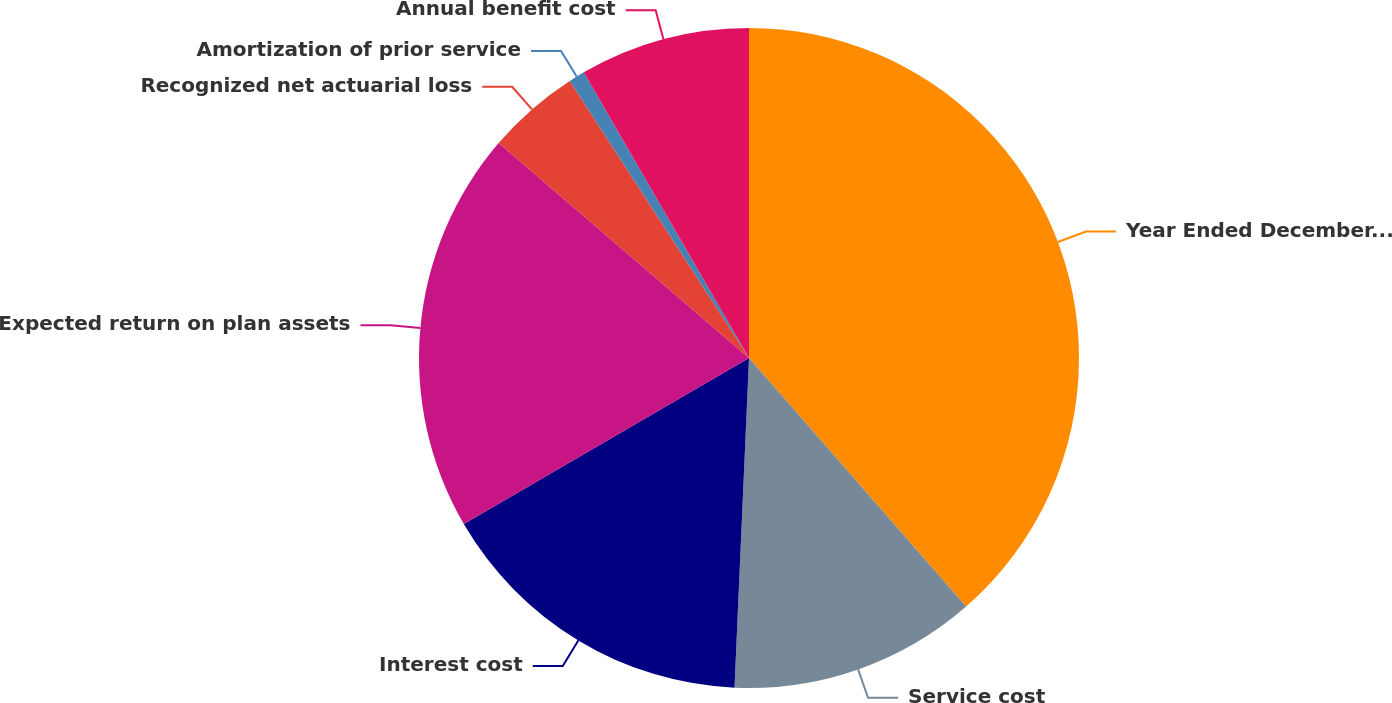Convert chart to OTSL. <chart><loc_0><loc_0><loc_500><loc_500><pie_chart><fcel>Year Ended December 31<fcel>Service cost<fcel>Interest cost<fcel>Expected return on plan assets<fcel>Recognized net actuarial loss<fcel>Amortization of prior service<fcel>Annual benefit cost<nl><fcel>38.58%<fcel>12.13%<fcel>15.91%<fcel>19.69%<fcel>4.57%<fcel>0.79%<fcel>8.35%<nl></chart> 